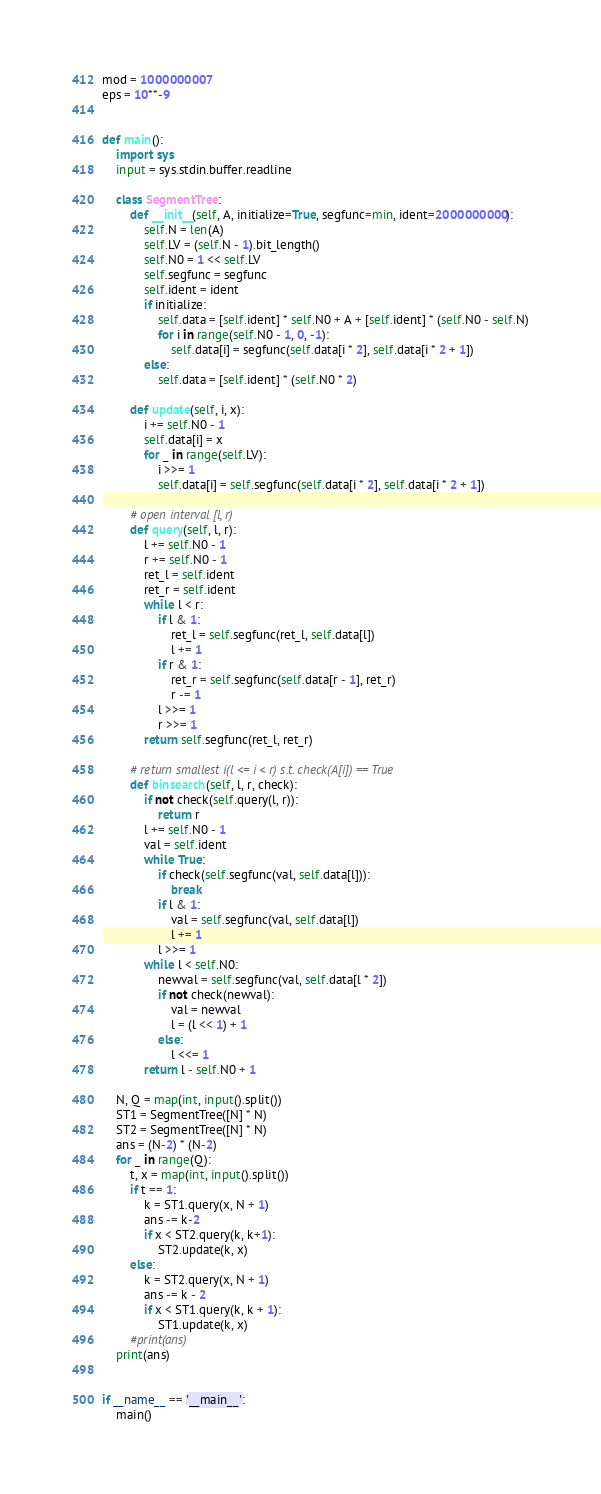Convert code to text. <code><loc_0><loc_0><loc_500><loc_500><_Python_>mod = 1000000007
eps = 10**-9


def main():
    import sys
    input = sys.stdin.buffer.readline

    class SegmentTree:
        def __init__(self, A, initialize=True, segfunc=min, ident=2000000000):
            self.N = len(A)
            self.LV = (self.N - 1).bit_length()
            self.N0 = 1 << self.LV
            self.segfunc = segfunc
            self.ident = ident
            if initialize:
                self.data = [self.ident] * self.N0 + A + [self.ident] * (self.N0 - self.N)
                for i in range(self.N0 - 1, 0, -1):
                    self.data[i] = segfunc(self.data[i * 2], self.data[i * 2 + 1])
            else:
                self.data = [self.ident] * (self.N0 * 2)

        def update(self, i, x):
            i += self.N0 - 1
            self.data[i] = x
            for _ in range(self.LV):
                i >>= 1
                self.data[i] = self.segfunc(self.data[i * 2], self.data[i * 2 + 1])

        # open interval [l, r)
        def query(self, l, r):
            l += self.N0 - 1
            r += self.N0 - 1
            ret_l = self.ident
            ret_r = self.ident
            while l < r:
                if l & 1:
                    ret_l = self.segfunc(ret_l, self.data[l])
                    l += 1
                if r & 1:
                    ret_r = self.segfunc(self.data[r - 1], ret_r)
                    r -= 1
                l >>= 1
                r >>= 1
            return self.segfunc(ret_l, ret_r)

        # return smallest i(l <= i < r) s.t. check(A[i]) == True
        def binsearch(self, l, r, check):
            if not check(self.query(l, r)):
                return r
            l += self.N0 - 1
            val = self.ident
            while True:
                if check(self.segfunc(val, self.data[l])):
                    break
                if l & 1:
                    val = self.segfunc(val, self.data[l])
                    l += 1
                l >>= 1
            while l < self.N0:
                newval = self.segfunc(val, self.data[l * 2])
                if not check(newval):
                    val = newval
                    l = (l << 1) + 1
                else:
                    l <<= 1
            return l - self.N0 + 1

    N, Q = map(int, input().split())
    ST1 = SegmentTree([N] * N)
    ST2 = SegmentTree([N] * N)
    ans = (N-2) * (N-2)
    for _ in range(Q):
        t, x = map(int, input().split())
        if t == 1:
            k = ST1.query(x, N + 1)
            ans -= k-2
            if x < ST2.query(k, k+1):
                ST2.update(k, x)
        else:
            k = ST2.query(x, N + 1)
            ans -= k - 2
            if x < ST1.query(k, k + 1):
                ST1.update(k, x)
        #print(ans)
    print(ans)


if __name__ == '__main__':
    main()
</code> 